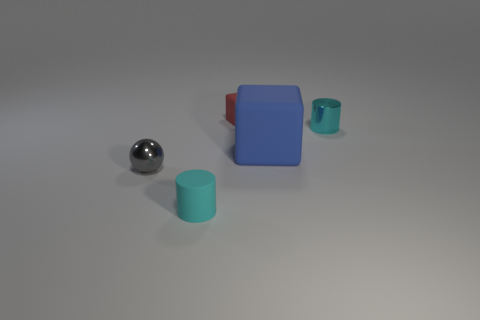There is a matte block that is in front of the tiny red rubber block; are there any blue rubber blocks in front of it?
Make the answer very short. No. There is another cylinder that is the same size as the shiny cylinder; what is its material?
Keep it short and to the point. Rubber. Is there a matte cube that has the same size as the gray thing?
Make the answer very short. Yes. What is the cyan thing that is behind the blue block made of?
Offer a very short reply. Metal. Is the small cylinder that is in front of the blue block made of the same material as the blue cube?
Your answer should be compact. Yes. What shape is the other matte object that is the same size as the red matte object?
Ensure brevity in your answer.  Cylinder. How many tiny objects have the same color as the rubber cylinder?
Provide a succinct answer. 1. Are there fewer metal objects to the left of the red rubber block than gray balls that are right of the small gray object?
Make the answer very short. No. Are there any small cyan cylinders on the left side of the blue thing?
Your response must be concise. Yes. There is a cyan cylinder behind the rubber thing that is in front of the gray metallic sphere; are there any tiny objects that are in front of it?
Offer a very short reply. Yes. 